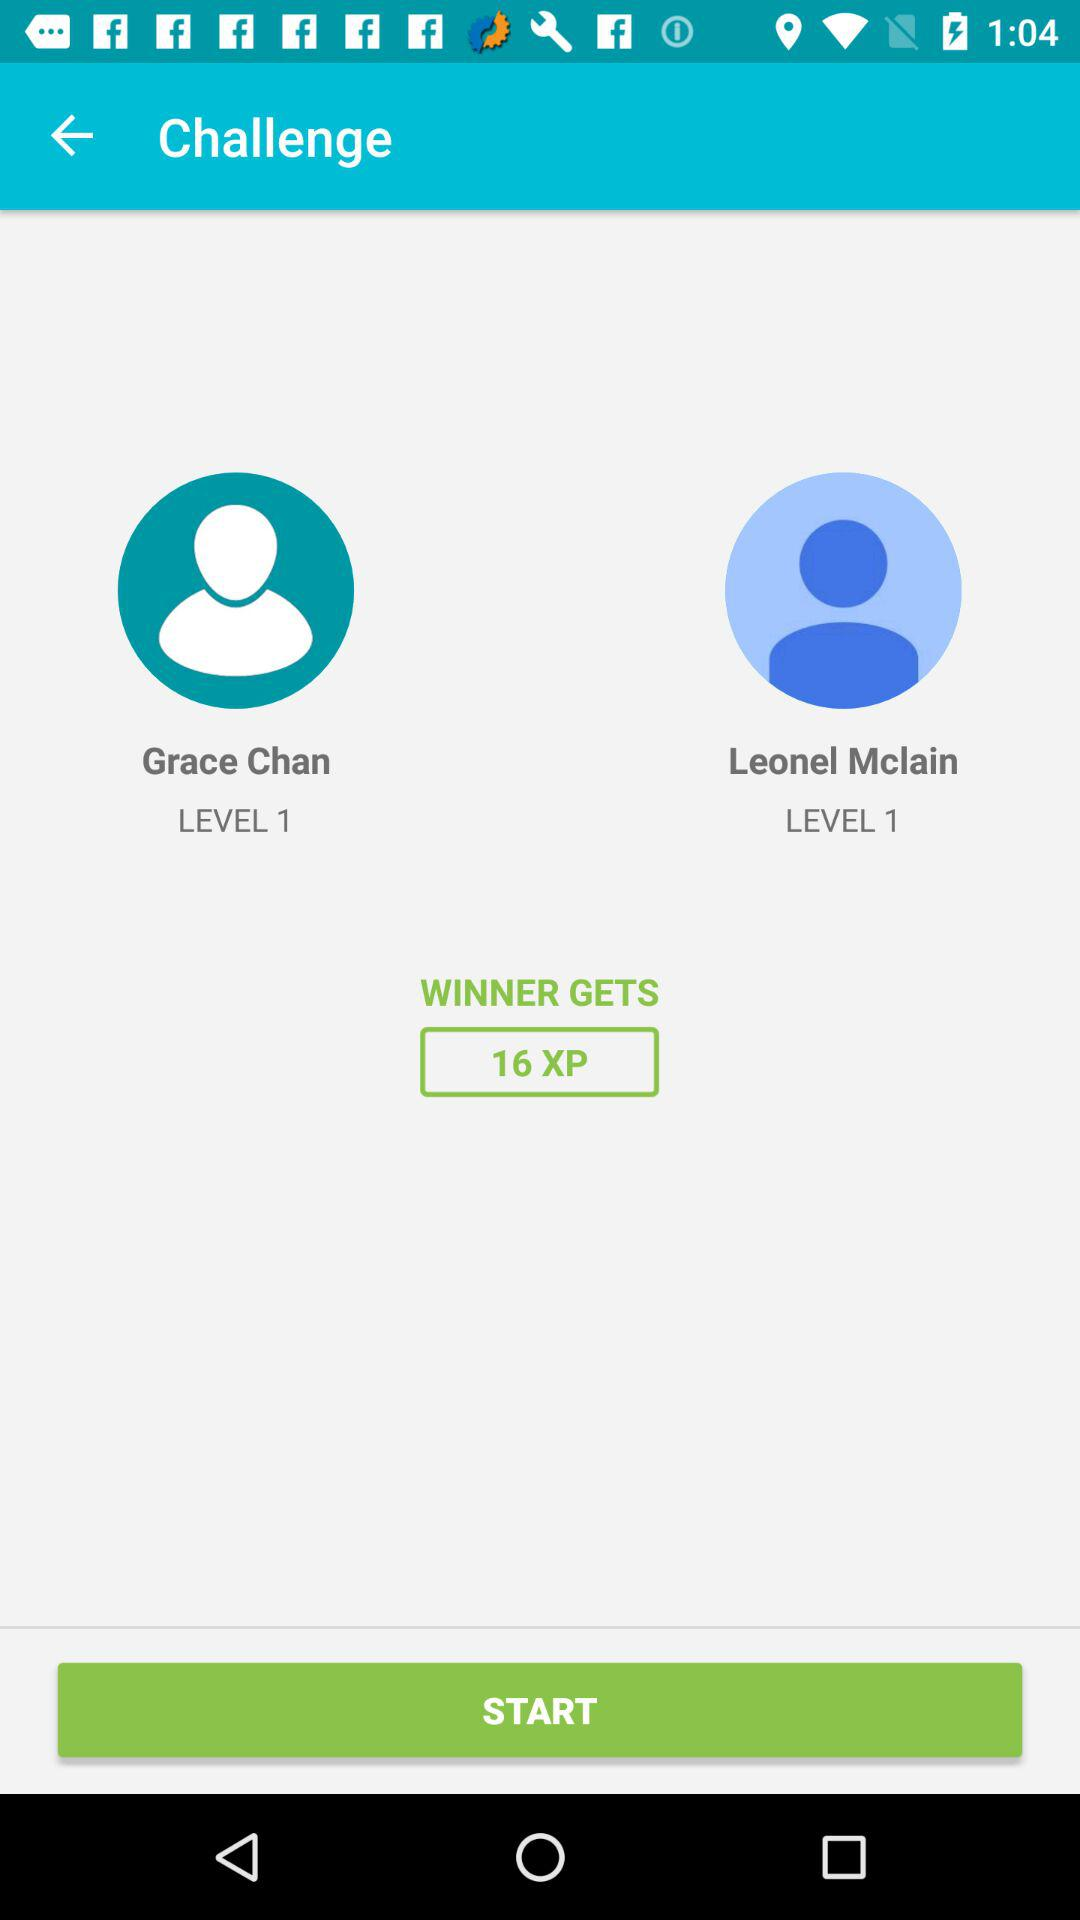If Grace Chan wins, how many XP will she earn?
Answer the question using a single word or phrase. 16 